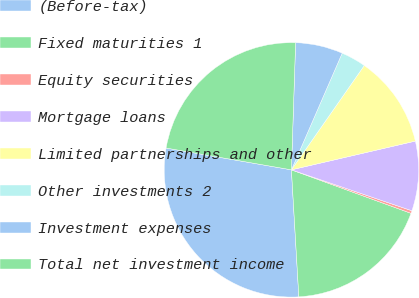Convert chart to OTSL. <chart><loc_0><loc_0><loc_500><loc_500><pie_chart><fcel>(Before-tax)<fcel>Fixed maturities 1<fcel>Equity securities<fcel>Mortgage loans<fcel>Limited partnerships and other<fcel>Other investments 2<fcel>Investment expenses<fcel>Total net investment income<nl><fcel>28.67%<fcel>18.52%<fcel>0.34%<fcel>8.84%<fcel>11.67%<fcel>3.17%<fcel>6.01%<fcel>22.78%<nl></chart> 